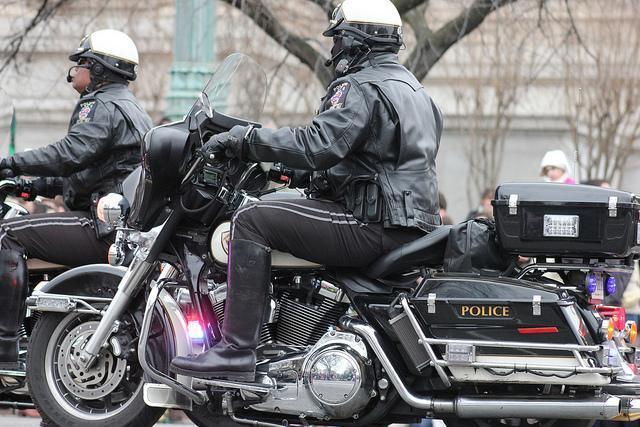How many police are in this photo?
Give a very brief answer. 2. How many tires are there?
Give a very brief answer. 2. How many people can be seen?
Give a very brief answer. 2. How many standing cows are there in the image ?
Give a very brief answer. 0. 